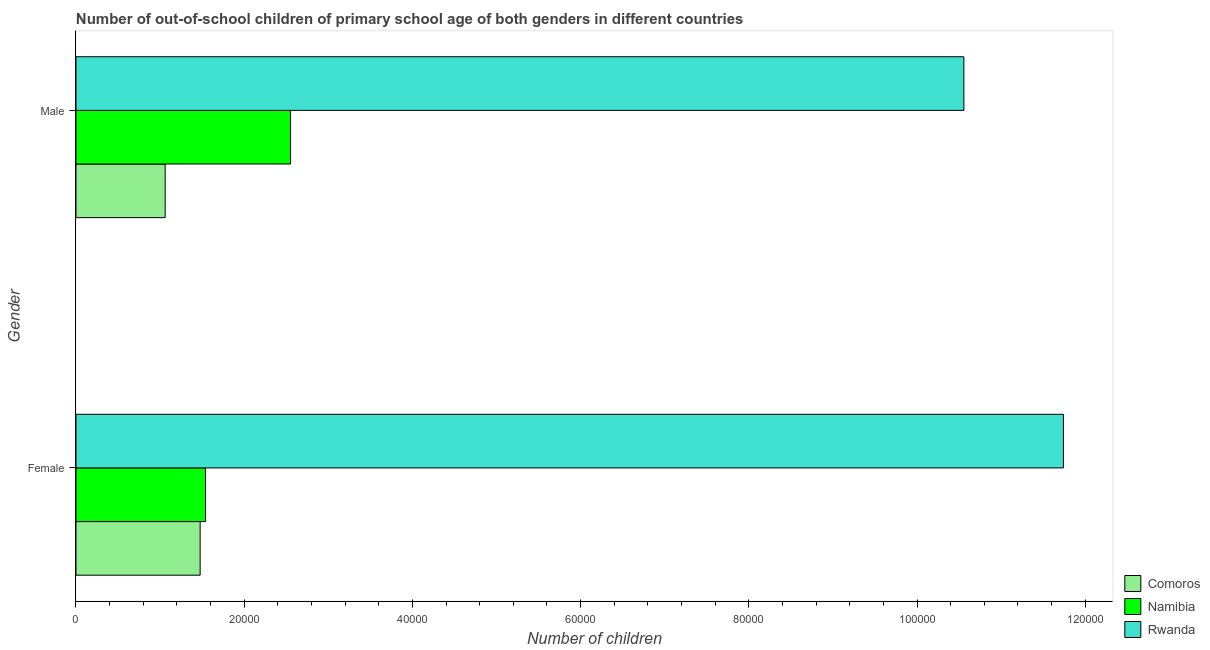Are the number of bars on each tick of the Y-axis equal?
Offer a terse response. Yes. How many bars are there on the 1st tick from the bottom?
Keep it short and to the point. 3. What is the label of the 1st group of bars from the top?
Your answer should be very brief. Male. What is the number of male out-of-school students in Namibia?
Keep it short and to the point. 2.55e+04. Across all countries, what is the maximum number of female out-of-school students?
Provide a succinct answer. 1.17e+05. Across all countries, what is the minimum number of male out-of-school students?
Your answer should be compact. 1.06e+04. In which country was the number of female out-of-school students maximum?
Offer a terse response. Rwanda. In which country was the number of female out-of-school students minimum?
Provide a short and direct response. Comoros. What is the total number of male out-of-school students in the graph?
Offer a terse response. 1.42e+05. What is the difference between the number of male out-of-school students in Namibia and that in Rwanda?
Offer a terse response. -8.01e+04. What is the difference between the number of female out-of-school students in Namibia and the number of male out-of-school students in Comoros?
Your answer should be compact. 4797. What is the average number of male out-of-school students per country?
Ensure brevity in your answer.  4.72e+04. What is the difference between the number of female out-of-school students and number of male out-of-school students in Comoros?
Your response must be concise. 4158. In how many countries, is the number of male out-of-school students greater than 60000 ?
Provide a short and direct response. 1. What is the ratio of the number of male out-of-school students in Namibia to that in Rwanda?
Offer a very short reply. 0.24. Is the number of male out-of-school students in Rwanda less than that in Namibia?
Your answer should be very brief. No. In how many countries, is the number of female out-of-school students greater than the average number of female out-of-school students taken over all countries?
Your answer should be compact. 1. What does the 2nd bar from the top in Male represents?
Your answer should be very brief. Namibia. What does the 2nd bar from the bottom in Male represents?
Ensure brevity in your answer.  Namibia. Are all the bars in the graph horizontal?
Offer a very short reply. Yes. Are the values on the major ticks of X-axis written in scientific E-notation?
Your answer should be compact. No. Does the graph contain any zero values?
Provide a short and direct response. No. Where does the legend appear in the graph?
Your answer should be very brief. Bottom right. How many legend labels are there?
Keep it short and to the point. 3. How are the legend labels stacked?
Provide a succinct answer. Vertical. What is the title of the graph?
Offer a very short reply. Number of out-of-school children of primary school age of both genders in different countries. What is the label or title of the X-axis?
Ensure brevity in your answer.  Number of children. What is the label or title of the Y-axis?
Make the answer very short. Gender. What is the Number of children in Comoros in Female?
Provide a succinct answer. 1.48e+04. What is the Number of children in Namibia in Female?
Provide a succinct answer. 1.54e+04. What is the Number of children in Rwanda in Female?
Offer a terse response. 1.17e+05. What is the Number of children in Comoros in Male?
Make the answer very short. 1.06e+04. What is the Number of children of Namibia in Male?
Provide a succinct answer. 2.55e+04. What is the Number of children of Rwanda in Male?
Provide a succinct answer. 1.06e+05. Across all Gender, what is the maximum Number of children of Comoros?
Provide a succinct answer. 1.48e+04. Across all Gender, what is the maximum Number of children in Namibia?
Provide a succinct answer. 2.55e+04. Across all Gender, what is the maximum Number of children of Rwanda?
Your response must be concise. 1.17e+05. Across all Gender, what is the minimum Number of children of Comoros?
Your answer should be very brief. 1.06e+04. Across all Gender, what is the minimum Number of children of Namibia?
Provide a short and direct response. 1.54e+04. Across all Gender, what is the minimum Number of children in Rwanda?
Give a very brief answer. 1.06e+05. What is the total Number of children in Comoros in the graph?
Offer a very short reply. 2.54e+04. What is the total Number of children in Namibia in the graph?
Your answer should be compact. 4.09e+04. What is the total Number of children in Rwanda in the graph?
Your answer should be very brief. 2.23e+05. What is the difference between the Number of children in Comoros in Female and that in Male?
Ensure brevity in your answer.  4158. What is the difference between the Number of children in Namibia in Female and that in Male?
Your response must be concise. -1.01e+04. What is the difference between the Number of children of Rwanda in Female and that in Male?
Give a very brief answer. 1.18e+04. What is the difference between the Number of children of Comoros in Female and the Number of children of Namibia in Male?
Provide a short and direct response. -1.08e+04. What is the difference between the Number of children of Comoros in Female and the Number of children of Rwanda in Male?
Offer a very short reply. -9.08e+04. What is the difference between the Number of children in Namibia in Female and the Number of children in Rwanda in Male?
Your answer should be very brief. -9.02e+04. What is the average Number of children of Comoros per Gender?
Your answer should be compact. 1.27e+04. What is the average Number of children of Namibia per Gender?
Provide a short and direct response. 2.05e+04. What is the average Number of children in Rwanda per Gender?
Provide a short and direct response. 1.11e+05. What is the difference between the Number of children in Comoros and Number of children in Namibia in Female?
Your answer should be very brief. -639. What is the difference between the Number of children of Comoros and Number of children of Rwanda in Female?
Your answer should be very brief. -1.03e+05. What is the difference between the Number of children of Namibia and Number of children of Rwanda in Female?
Keep it short and to the point. -1.02e+05. What is the difference between the Number of children of Comoros and Number of children of Namibia in Male?
Offer a very short reply. -1.49e+04. What is the difference between the Number of children of Comoros and Number of children of Rwanda in Male?
Offer a terse response. -9.50e+04. What is the difference between the Number of children of Namibia and Number of children of Rwanda in Male?
Your answer should be very brief. -8.01e+04. What is the ratio of the Number of children in Comoros in Female to that in Male?
Offer a very short reply. 1.39. What is the ratio of the Number of children of Namibia in Female to that in Male?
Your response must be concise. 0.6. What is the ratio of the Number of children in Rwanda in Female to that in Male?
Offer a very short reply. 1.11. What is the difference between the highest and the second highest Number of children of Comoros?
Provide a succinct answer. 4158. What is the difference between the highest and the second highest Number of children in Namibia?
Your answer should be very brief. 1.01e+04. What is the difference between the highest and the second highest Number of children in Rwanda?
Provide a succinct answer. 1.18e+04. What is the difference between the highest and the lowest Number of children of Comoros?
Your answer should be very brief. 4158. What is the difference between the highest and the lowest Number of children in Namibia?
Offer a very short reply. 1.01e+04. What is the difference between the highest and the lowest Number of children of Rwanda?
Offer a very short reply. 1.18e+04. 